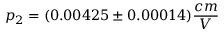Convert formula to latex. <formula><loc_0><loc_0><loc_500><loc_500>p _ { 2 } = ( 0 . 0 0 4 2 5 \pm 0 . 0 0 0 1 4 ) \frac { c m } { V }</formula> 